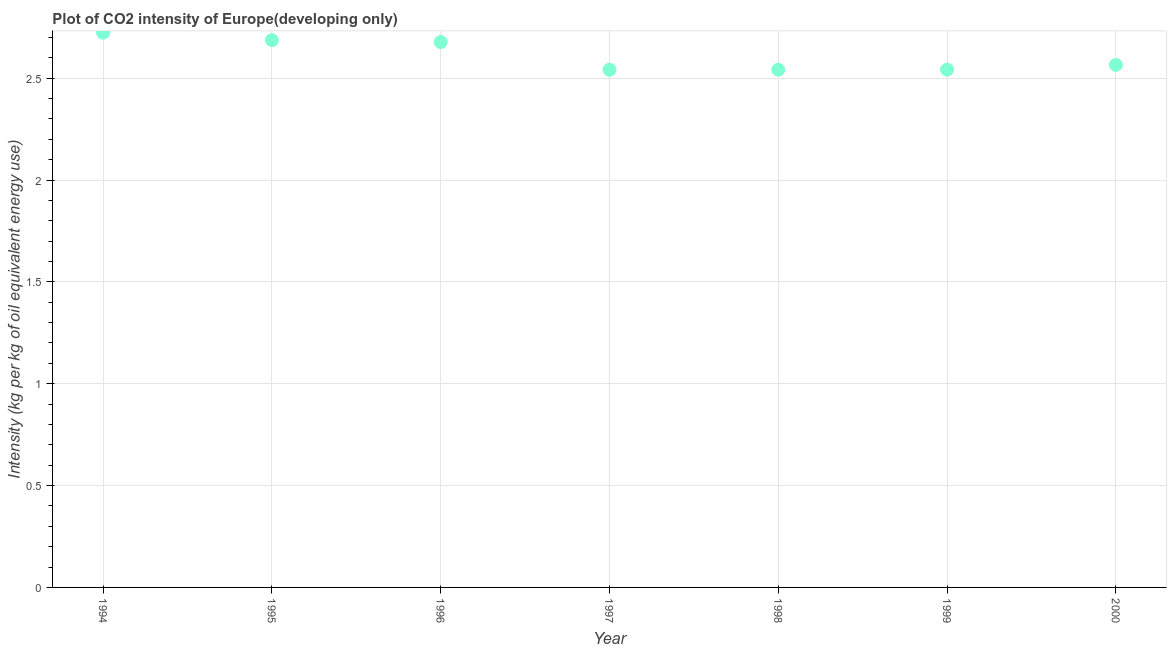What is the co2 intensity in 1994?
Provide a succinct answer. 2.72. Across all years, what is the maximum co2 intensity?
Keep it short and to the point. 2.72. Across all years, what is the minimum co2 intensity?
Ensure brevity in your answer.  2.54. In which year was the co2 intensity maximum?
Provide a short and direct response. 1994. In which year was the co2 intensity minimum?
Keep it short and to the point. 1997. What is the sum of the co2 intensity?
Your answer should be compact. 18.28. What is the difference between the co2 intensity in 1994 and 1997?
Your answer should be very brief. 0.18. What is the average co2 intensity per year?
Give a very brief answer. 2.61. What is the median co2 intensity?
Your response must be concise. 2.57. In how many years, is the co2 intensity greater than 0.30000000000000004 kg?
Make the answer very short. 7. What is the ratio of the co2 intensity in 1994 to that in 2000?
Give a very brief answer. 1.06. Is the co2 intensity in 1994 less than that in 1998?
Offer a terse response. No. What is the difference between the highest and the second highest co2 intensity?
Your answer should be very brief. 0.04. What is the difference between the highest and the lowest co2 intensity?
Your answer should be compact. 0.18. How many years are there in the graph?
Make the answer very short. 7. Are the values on the major ticks of Y-axis written in scientific E-notation?
Make the answer very short. No. Does the graph contain any zero values?
Provide a short and direct response. No. What is the title of the graph?
Offer a terse response. Plot of CO2 intensity of Europe(developing only). What is the label or title of the X-axis?
Keep it short and to the point. Year. What is the label or title of the Y-axis?
Offer a terse response. Intensity (kg per kg of oil equivalent energy use). What is the Intensity (kg per kg of oil equivalent energy use) in 1994?
Make the answer very short. 2.72. What is the Intensity (kg per kg of oil equivalent energy use) in 1995?
Make the answer very short. 2.69. What is the Intensity (kg per kg of oil equivalent energy use) in 1996?
Give a very brief answer. 2.68. What is the Intensity (kg per kg of oil equivalent energy use) in 1997?
Your answer should be compact. 2.54. What is the Intensity (kg per kg of oil equivalent energy use) in 1998?
Your answer should be compact. 2.54. What is the Intensity (kg per kg of oil equivalent energy use) in 1999?
Give a very brief answer. 2.54. What is the Intensity (kg per kg of oil equivalent energy use) in 2000?
Make the answer very short. 2.57. What is the difference between the Intensity (kg per kg of oil equivalent energy use) in 1994 and 1995?
Keep it short and to the point. 0.04. What is the difference between the Intensity (kg per kg of oil equivalent energy use) in 1994 and 1996?
Offer a very short reply. 0.05. What is the difference between the Intensity (kg per kg of oil equivalent energy use) in 1994 and 1997?
Make the answer very short. 0.18. What is the difference between the Intensity (kg per kg of oil equivalent energy use) in 1994 and 1998?
Provide a succinct answer. 0.18. What is the difference between the Intensity (kg per kg of oil equivalent energy use) in 1994 and 1999?
Offer a very short reply. 0.18. What is the difference between the Intensity (kg per kg of oil equivalent energy use) in 1994 and 2000?
Your answer should be very brief. 0.16. What is the difference between the Intensity (kg per kg of oil equivalent energy use) in 1995 and 1996?
Your answer should be compact. 0.01. What is the difference between the Intensity (kg per kg of oil equivalent energy use) in 1995 and 1997?
Keep it short and to the point. 0.15. What is the difference between the Intensity (kg per kg of oil equivalent energy use) in 1995 and 1998?
Make the answer very short. 0.15. What is the difference between the Intensity (kg per kg of oil equivalent energy use) in 1995 and 1999?
Your answer should be very brief. 0.14. What is the difference between the Intensity (kg per kg of oil equivalent energy use) in 1995 and 2000?
Offer a terse response. 0.12. What is the difference between the Intensity (kg per kg of oil equivalent energy use) in 1996 and 1997?
Your response must be concise. 0.14. What is the difference between the Intensity (kg per kg of oil equivalent energy use) in 1996 and 1998?
Keep it short and to the point. 0.14. What is the difference between the Intensity (kg per kg of oil equivalent energy use) in 1996 and 1999?
Give a very brief answer. 0.14. What is the difference between the Intensity (kg per kg of oil equivalent energy use) in 1996 and 2000?
Offer a very short reply. 0.11. What is the difference between the Intensity (kg per kg of oil equivalent energy use) in 1997 and 1998?
Offer a very short reply. -5e-5. What is the difference between the Intensity (kg per kg of oil equivalent energy use) in 1997 and 1999?
Give a very brief answer. -0. What is the difference between the Intensity (kg per kg of oil equivalent energy use) in 1997 and 2000?
Provide a succinct answer. -0.02. What is the difference between the Intensity (kg per kg of oil equivalent energy use) in 1998 and 1999?
Your answer should be compact. -0. What is the difference between the Intensity (kg per kg of oil equivalent energy use) in 1998 and 2000?
Offer a terse response. -0.02. What is the difference between the Intensity (kg per kg of oil equivalent energy use) in 1999 and 2000?
Offer a very short reply. -0.02. What is the ratio of the Intensity (kg per kg of oil equivalent energy use) in 1994 to that in 1997?
Provide a succinct answer. 1.07. What is the ratio of the Intensity (kg per kg of oil equivalent energy use) in 1994 to that in 1998?
Ensure brevity in your answer.  1.07. What is the ratio of the Intensity (kg per kg of oil equivalent energy use) in 1994 to that in 1999?
Offer a very short reply. 1.07. What is the ratio of the Intensity (kg per kg of oil equivalent energy use) in 1994 to that in 2000?
Your answer should be very brief. 1.06. What is the ratio of the Intensity (kg per kg of oil equivalent energy use) in 1995 to that in 1997?
Provide a succinct answer. 1.06. What is the ratio of the Intensity (kg per kg of oil equivalent energy use) in 1995 to that in 1998?
Your response must be concise. 1.06. What is the ratio of the Intensity (kg per kg of oil equivalent energy use) in 1995 to that in 1999?
Provide a short and direct response. 1.06. What is the ratio of the Intensity (kg per kg of oil equivalent energy use) in 1995 to that in 2000?
Give a very brief answer. 1.05. What is the ratio of the Intensity (kg per kg of oil equivalent energy use) in 1996 to that in 1997?
Provide a short and direct response. 1.05. What is the ratio of the Intensity (kg per kg of oil equivalent energy use) in 1996 to that in 1998?
Your answer should be very brief. 1.05. What is the ratio of the Intensity (kg per kg of oil equivalent energy use) in 1996 to that in 1999?
Your answer should be very brief. 1.05. What is the ratio of the Intensity (kg per kg of oil equivalent energy use) in 1996 to that in 2000?
Your answer should be compact. 1.04. What is the ratio of the Intensity (kg per kg of oil equivalent energy use) in 1997 to that in 1999?
Offer a terse response. 1. What is the ratio of the Intensity (kg per kg of oil equivalent energy use) in 1998 to that in 1999?
Offer a terse response. 1. What is the ratio of the Intensity (kg per kg of oil equivalent energy use) in 1998 to that in 2000?
Make the answer very short. 0.99. 